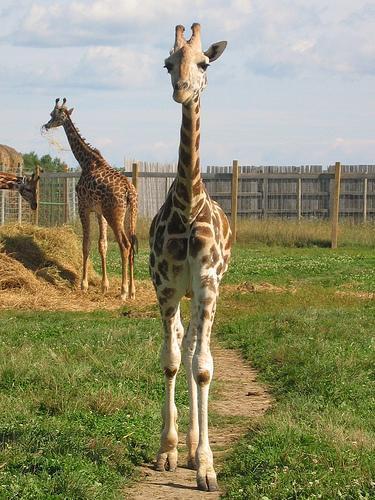How many giraffes?
Give a very brief answer. 3. How many giraffes can you see?
Give a very brief answer. 2. How many people are visible in this picture?
Give a very brief answer. 0. 